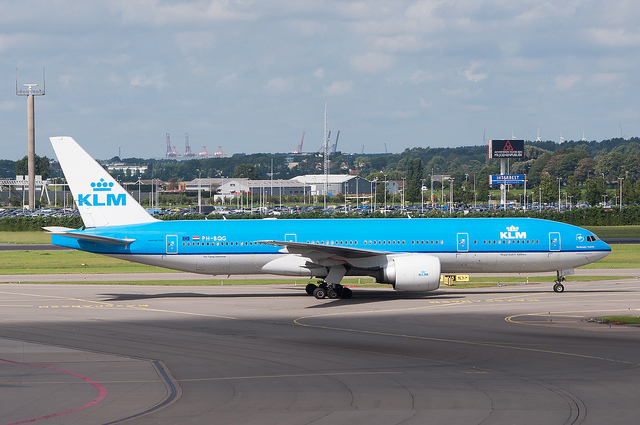Read and extract the text from this image. KLM KLM 